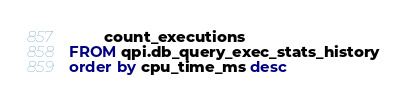<code> <loc_0><loc_0><loc_500><loc_500><_SQL_>        count_executions
FROM qpi.db_query_exec_stats_history
order by cpu_time_ms desc

</code> 